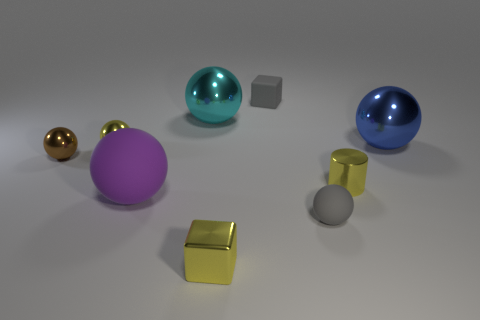Subtract all blue spheres. How many spheres are left? 5 Subtract all yellow balls. How many balls are left? 5 Subtract all green spheres. Subtract all brown cubes. How many spheres are left? 6 Subtract all cylinders. How many objects are left? 8 Add 8 small yellow cubes. How many small yellow cubes exist? 9 Subtract 1 gray cubes. How many objects are left? 8 Subtract all matte balls. Subtract all small gray cylinders. How many objects are left? 7 Add 5 large rubber objects. How many large rubber objects are left? 6 